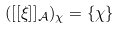Convert formula to latex. <formula><loc_0><loc_0><loc_500><loc_500>( [ [ \xi ] ] _ { \mathcal { A } } ) _ { \chi } = \{ \chi \}</formula> 